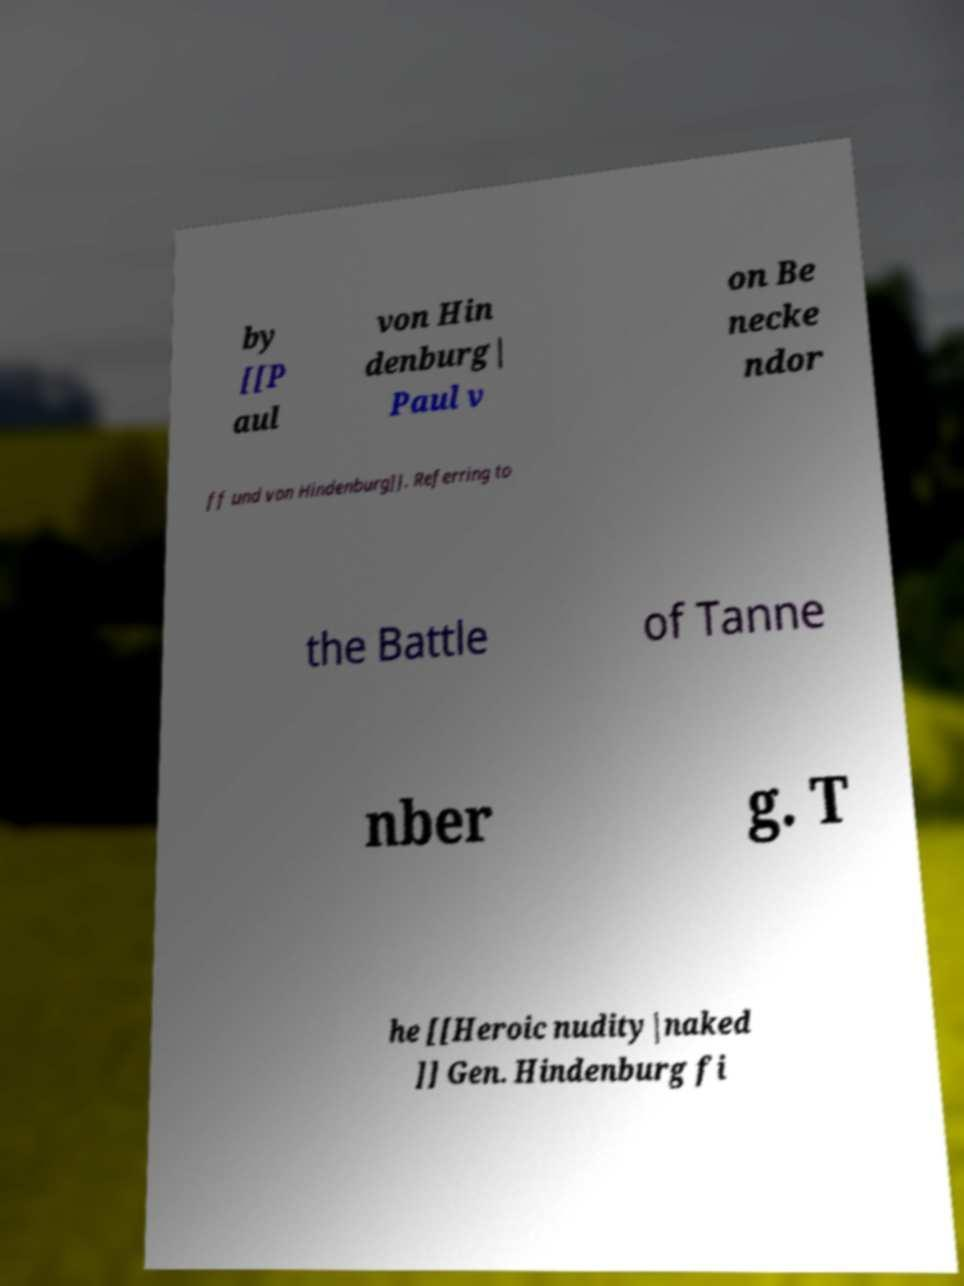For documentation purposes, I need the text within this image transcribed. Could you provide that? by [[P aul von Hin denburg| Paul v on Be necke ndor ff und von Hindenburg]]. Referring to the Battle of Tanne nber g. T he [[Heroic nudity|naked ]] Gen. Hindenburg fi 